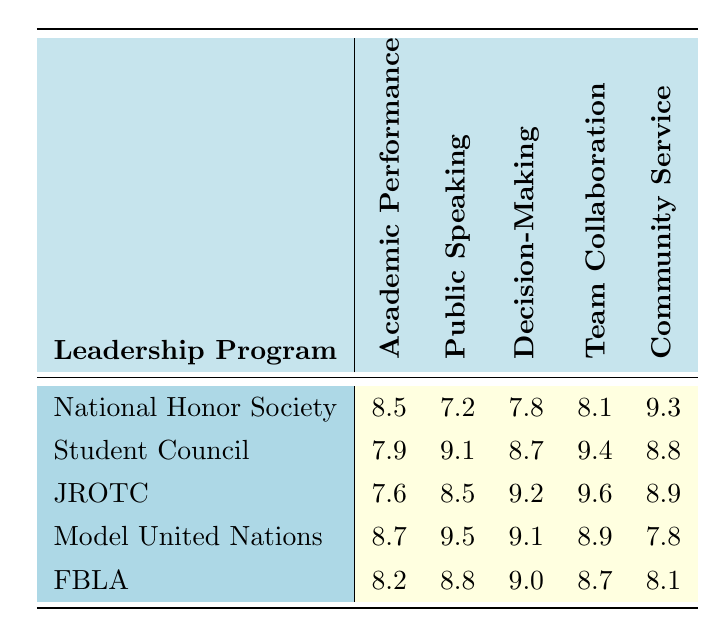What is the effectiveness score of the National Honor Society in Community Service Engagement? According to the table, the effectiveness score for the National Honor Society in Community Service Engagement is found under that specific category, which is 9.3.
Answer: 9.3 Which program has the highest score in Confidence in Public Speaking? By reviewing the scores for Confidence in Public Speaking, Model United Nations has the highest score of 9.5.
Answer: Model United Nations What is the average score for Decision-Making Skills across all programs? To calculate the average, sum the scores for Decision-Making Skills: 7.8 (NHS) + 8.7 (Student Council) + 9.2 (JROTC) + 9.1 (Model United Nations) + 9.0 (FBLA) = 44.8. Then divide by the number of programs, which is 5, giving an average of 44.8 / 5 = 8.96.
Answer: 8.96 Is the score for Team Collaboration in JROTC higher than in Student Council? The scores indicate JROTC has 9.6 and Student Council has 9.4 in Team Collaboration. Since 9.6 is greater than 9.4, the statement is true.
Answer: Yes Which program has the lowest score in Academic Performance Improvement? Reviewing the scores in Academic Performance Improvement, JROTC has the lowest score of 7.6 among all programs listed.
Answer: JROTC If we consider Community Service Engagement and Decision-Making Skills, which program has the highest combined score? The combined scores for each program are: NHS (9.3 + 7.8 = 17.1), Student Council (8.8 + 8.7 = 17.5), JROTC (8.9 + 9.2 = 18.1), Model United Nations (7.8 + 9.1 = 16.9), and FBLA (8.1 + 9.0 = 17.1). JROTC has the highest combined score of 18.1.
Answer: JROTC What is the difference between the scores for Academic Performance Improvement of Model United Nations and Student Council? To find the difference, subtract the score of Student Council (7.9) from that of Model United Nations (8.7): 8.7 - 7.9 = 0.8.
Answer: 0.8 Do both the NHS and FBLA programs have Community Service Engagement scores above 8? NHS has a score of 9.3 and FBLA has a score of 8.1 for Community Service Engagement. Since 9.3 > 8 and 8.1 > 8, the answer is true for NHS but not for FBLA.
Answer: No Which program scores highest in Team Collaboration, and what is its score? When comparing the Team Collaboration scores, JROTC scores 9.6, which is the highest among all the listed programs.
Answer: JROTC, 9.6 If the scores for Confidence in Public Speaking were to be averaged, what would that average be? Summing the scores: 7.2 (NHS) + 9.1 (Student Council) + 8.5 (JROTC) + 9.5 (Model United Nations) + 8.8 (FBLA) = 43.1. Now, dividing by 5 gives an average of 43.1 / 5 = 8.62.
Answer: 8.62 What is the score for Team Collaboration in the Future Business Leaders of America program? The score for Team Collaboration in the Future Business Leaders of America program is directly listed in the table as 8.7.
Answer: 8.7 